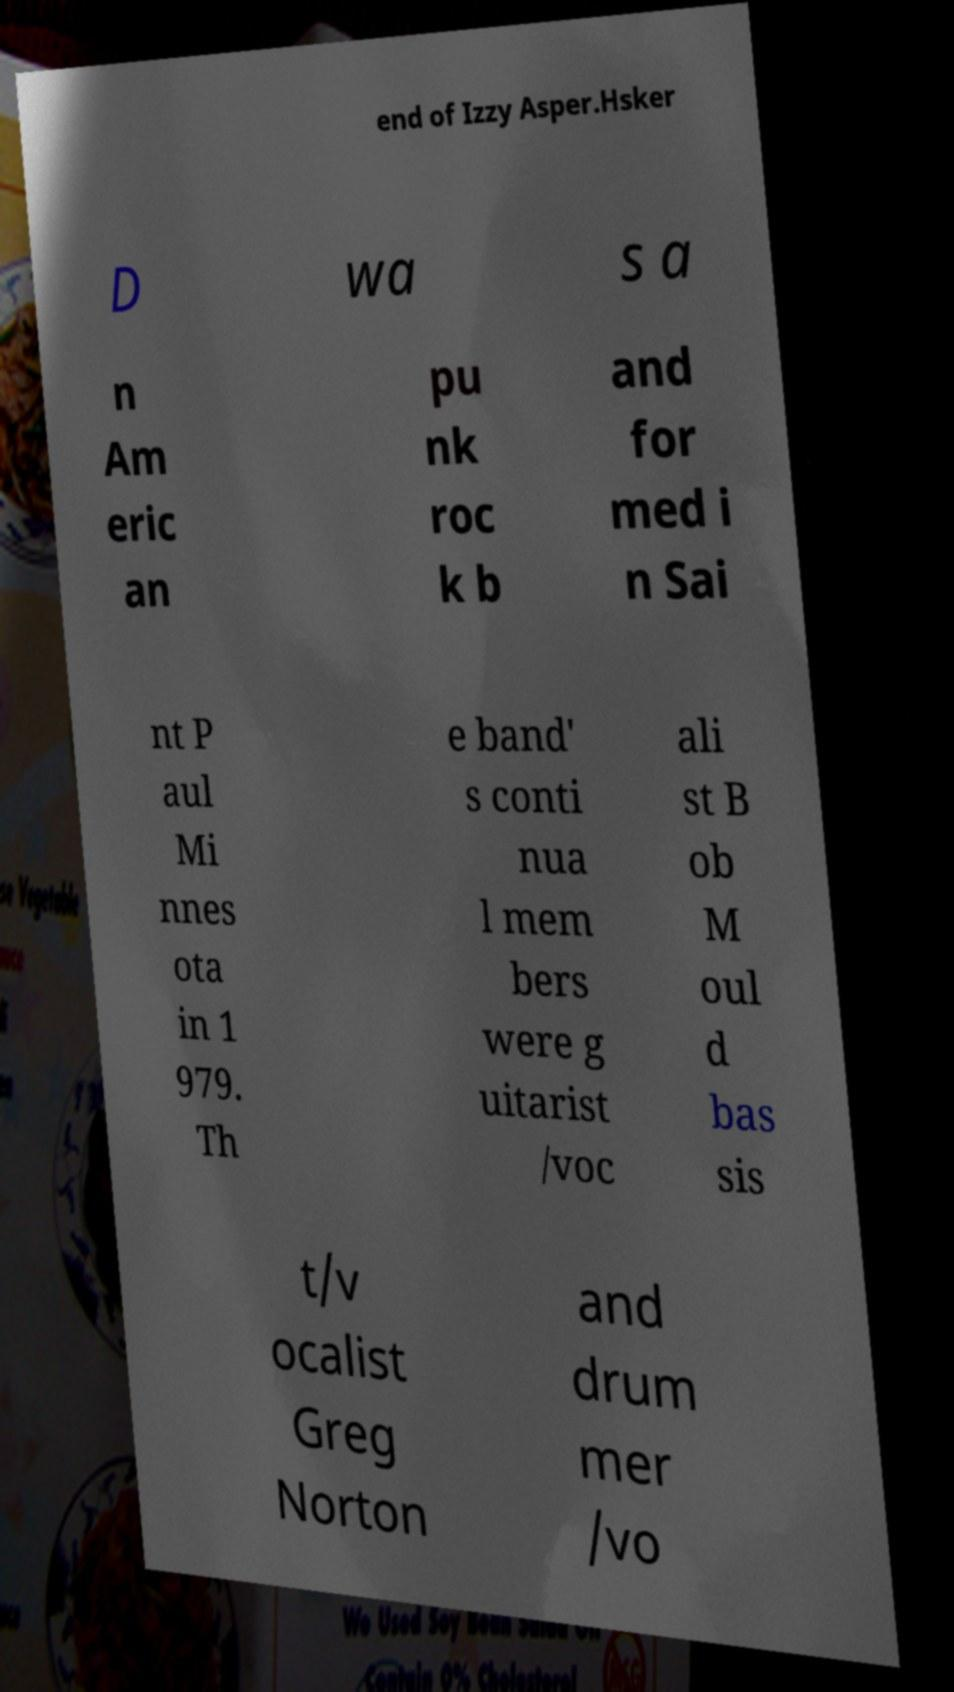Can you accurately transcribe the text from the provided image for me? end of Izzy Asper.Hsker D wa s a n Am eric an pu nk roc k b and for med i n Sai nt P aul Mi nnes ota in 1 979. Th e band' s conti nua l mem bers were g uitarist /voc ali st B ob M oul d bas sis t/v ocalist Greg Norton and drum mer /vo 